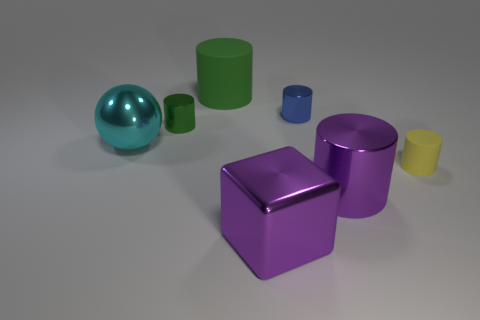Subtract all tiny blue shiny cylinders. How many cylinders are left? 4 Subtract all green balls. How many green cylinders are left? 2 Subtract all blue cylinders. How many cylinders are left? 4 Add 1 big spheres. How many objects exist? 8 Subtract all gray cylinders. Subtract all brown blocks. How many cylinders are left? 5 Subtract all balls. How many objects are left? 6 Subtract all blocks. Subtract all blue metal cylinders. How many objects are left? 5 Add 5 purple cylinders. How many purple cylinders are left? 6 Add 5 large gray metal blocks. How many large gray metal blocks exist? 5 Subtract 2 green cylinders. How many objects are left? 5 